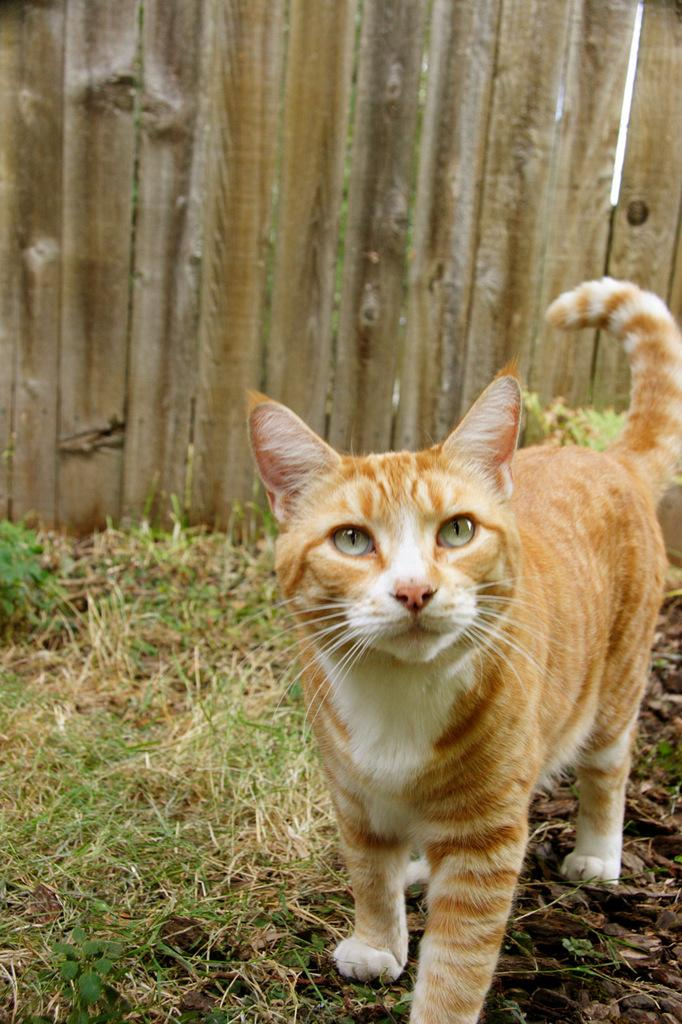What type of animal is in the image? There is a cat in the image. What is the cat doing in the image? The cat is standing on the ground. What type of surface is the cat standing on? There is grass on the ground. What can be seen in the background of the image? There is a wooden wall in the background of the image. How many kittens are wearing a veil in the image? There are no kittens or veils present in the image; it features a cat standing on grass with a wooden wall in the background. 